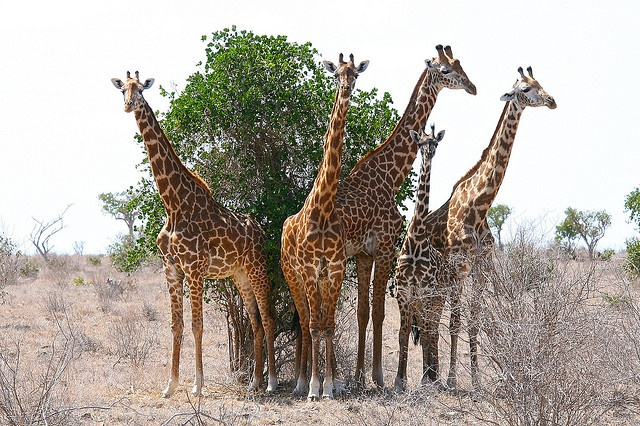Describe the objects in this image and their specific colors. I can see giraffe in white, maroon, black, and gray tones, giraffe in white, black, maroon, and gray tones, giraffe in white, gray, darkgray, and black tones, giraffe in white, maroon, black, and gray tones, and giraffe in white, black, gray, and darkgray tones in this image. 